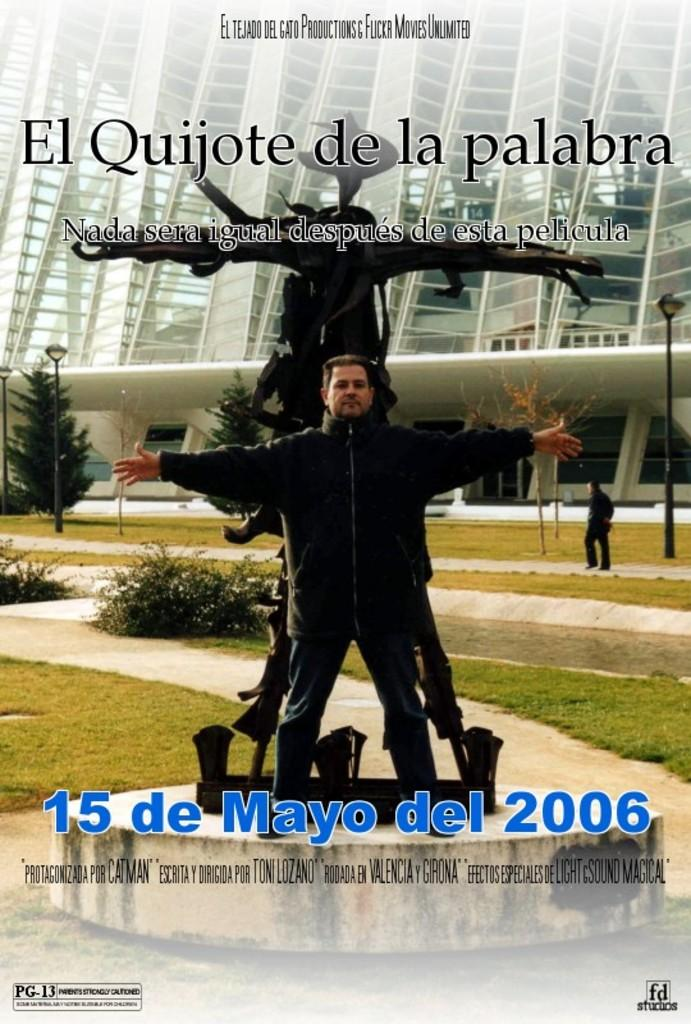Provide a one-sentence caption for the provided image. an ad about a movie entitled El Quijote de la palabra. 